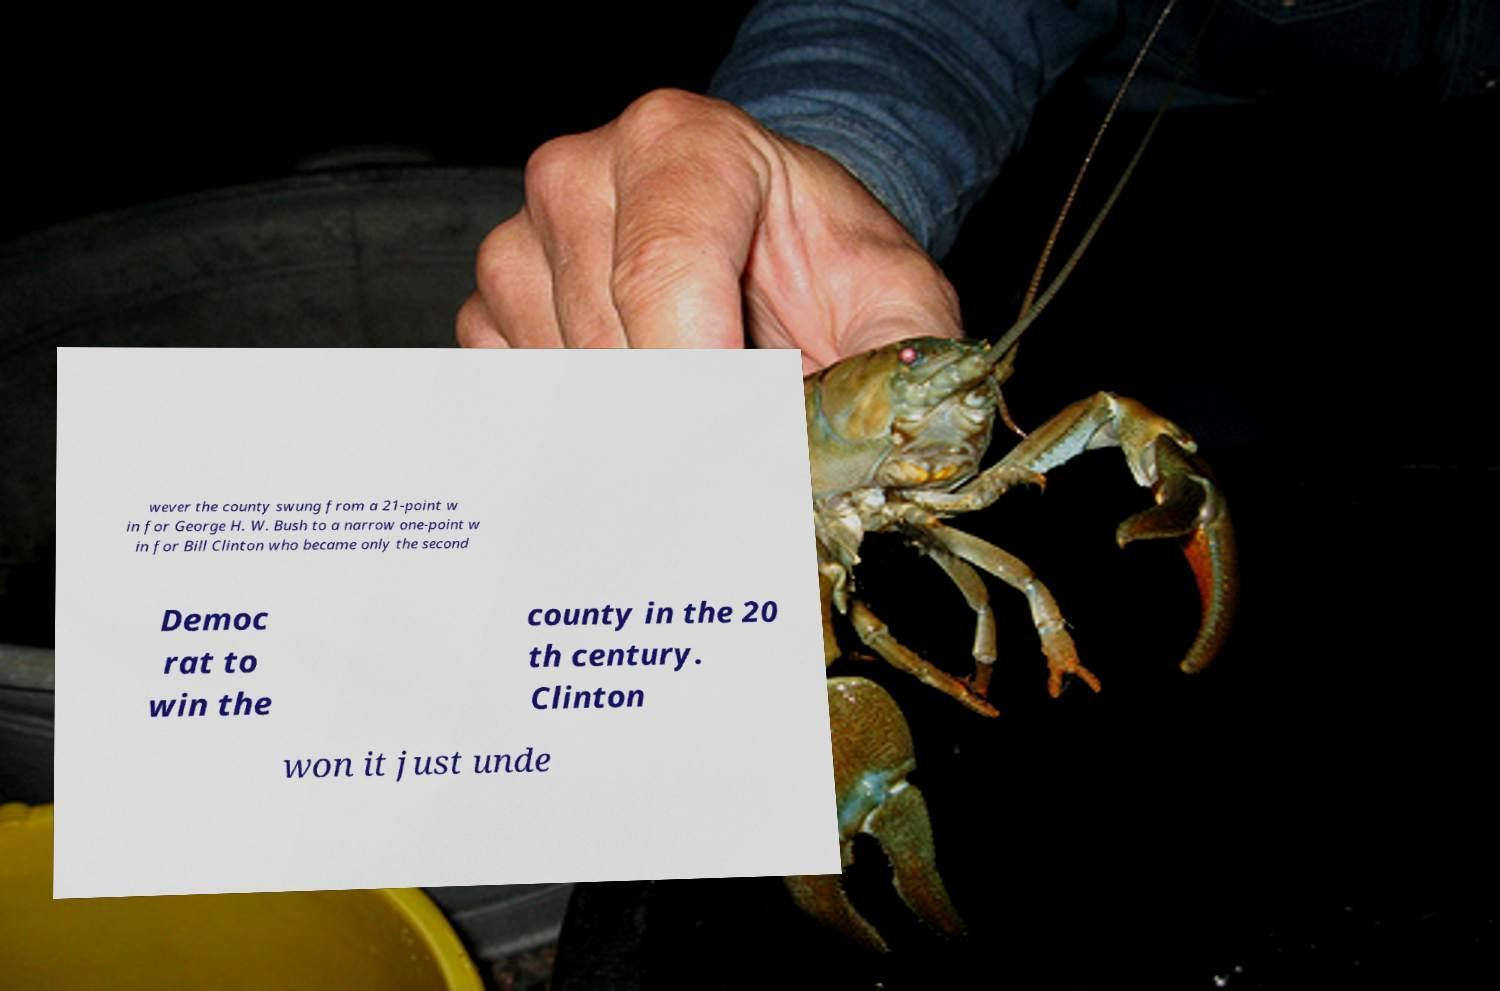Can you accurately transcribe the text from the provided image for me? wever the county swung from a 21-point w in for George H. W. Bush to a narrow one-point w in for Bill Clinton who became only the second Democ rat to win the county in the 20 th century. Clinton won it just unde 